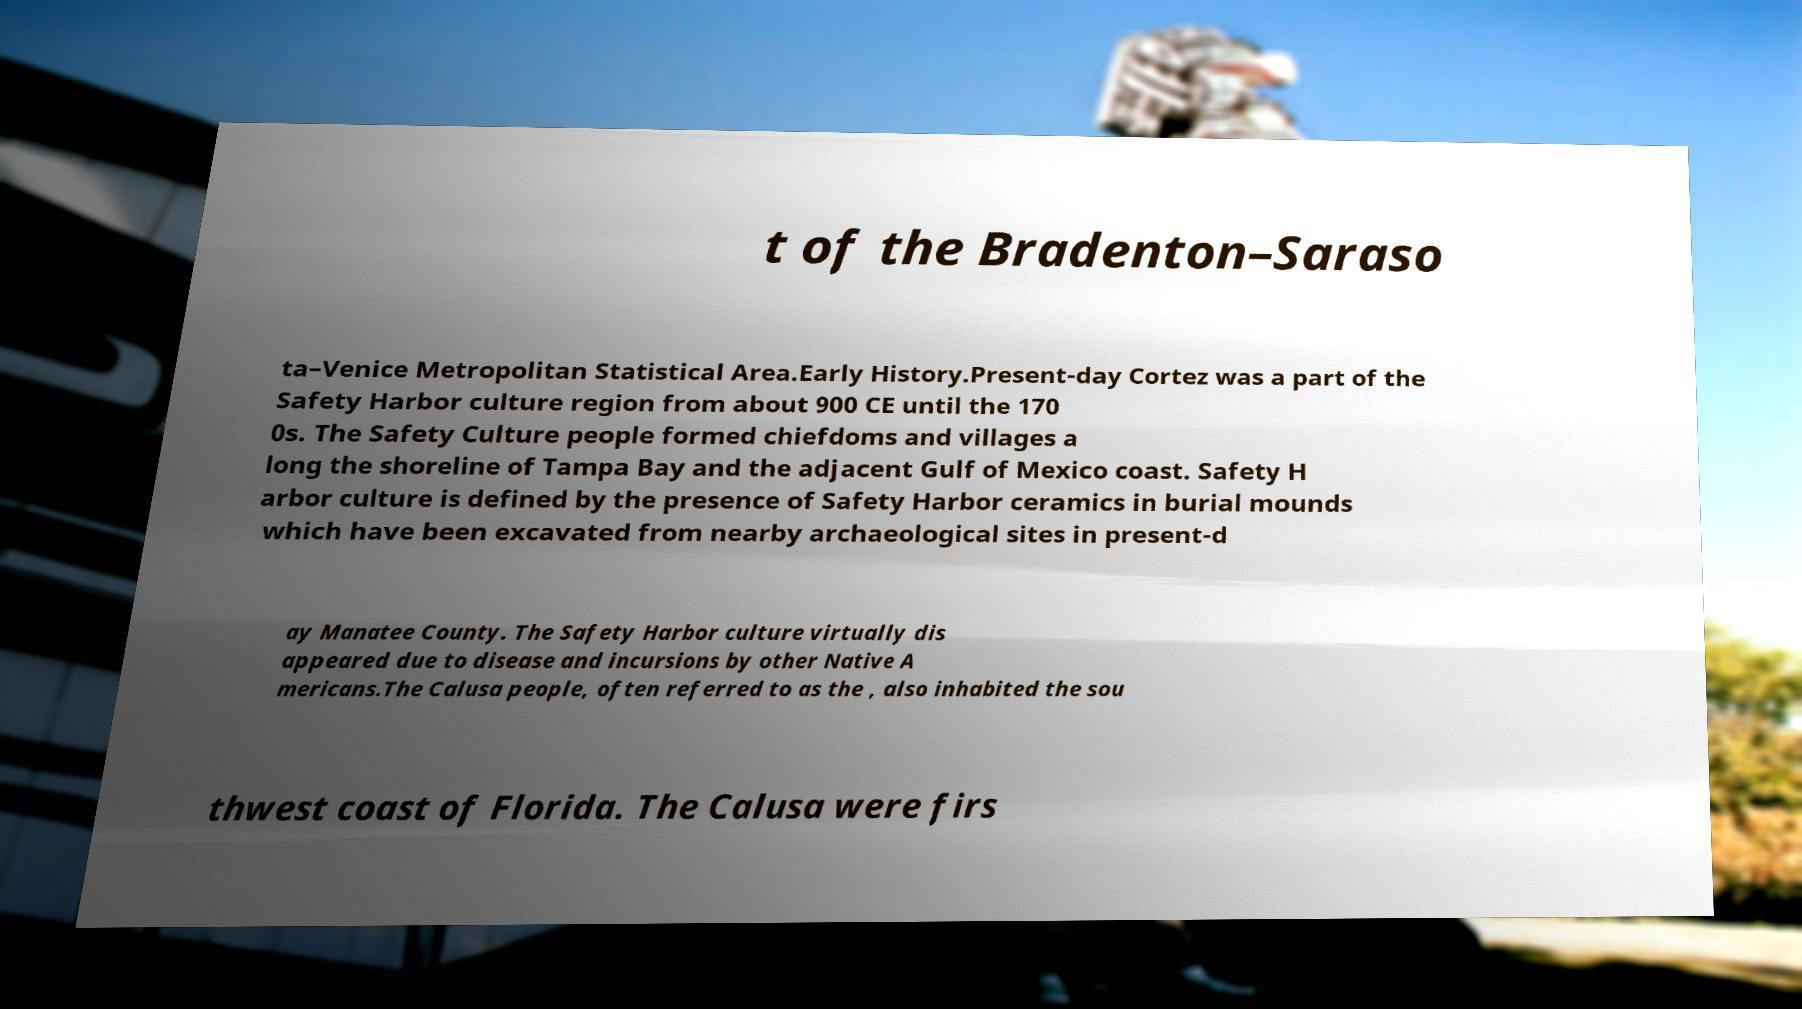Can you accurately transcribe the text from the provided image for me? t of the Bradenton–Saraso ta–Venice Metropolitan Statistical Area.Early History.Present-day Cortez was a part of the Safety Harbor culture region from about 900 CE until the 170 0s. The Safety Culture people formed chiefdoms and villages a long the shoreline of Tampa Bay and the adjacent Gulf of Mexico coast. Safety H arbor culture is defined by the presence of Safety Harbor ceramics in burial mounds which have been excavated from nearby archaeological sites in present-d ay Manatee County. The Safety Harbor culture virtually dis appeared due to disease and incursions by other Native A mericans.The Calusa people, often referred to as the , also inhabited the sou thwest coast of Florida. The Calusa were firs 